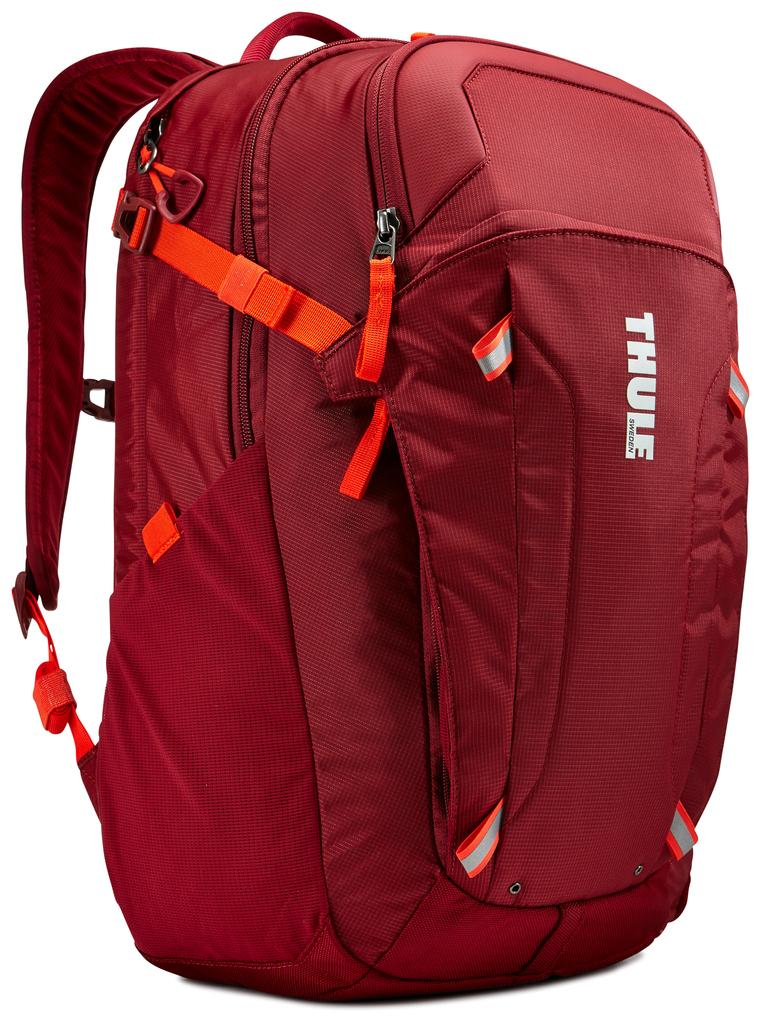Provide a one-sentence caption for the provided image. A red THULE backpack with orange straps placed against white background. 